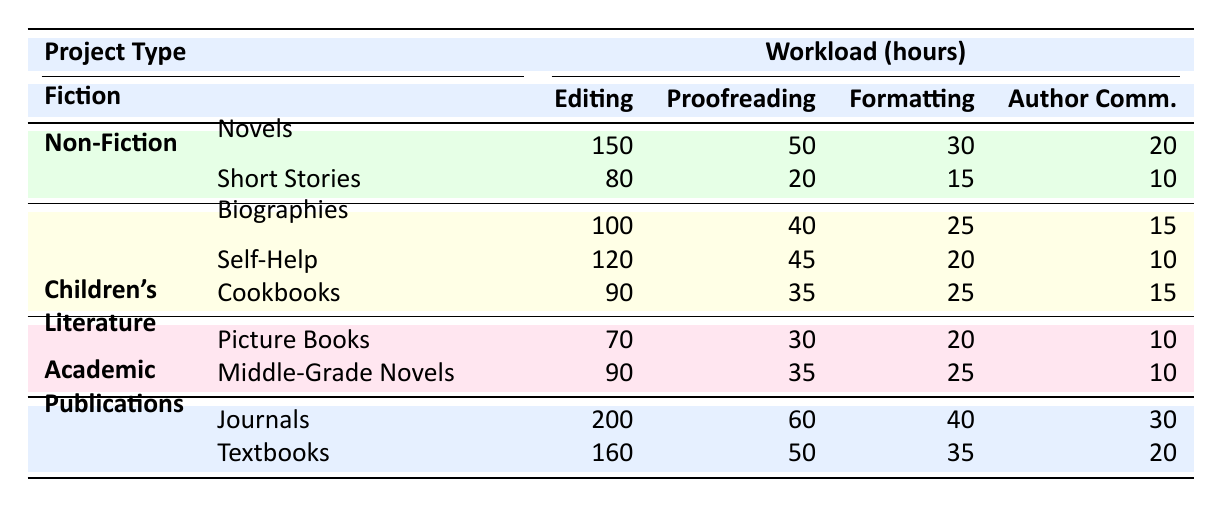What is the total editing workload for Fiction? The total editing workload for Fiction includes the editing hours for Novels (150) and Short Stories (80). Therefore, the total is calculated as 150 + 80 = 230 hours.
Answer: 230 Which project type has the highest proofreading workload? Looking at the proofreading workloads, Fiction (70), Non-Fiction (120), Children's Literature (65), and Academic Publications (110). The highest proofreading workload is for Academic Publications (60), specifically from Journals (60).
Answer: Academic Publications What is the average formatting workload for Non-Fiction? For Non-Fiction, the formatting workloads are Cookbooks (25), Biographies (25), and Self-Help (20). The total is 25 + 25 + 20 = 70. There are 3 projects, so the average is 70 / 3 = 23.33 hours.
Answer: 23.33 Is the Author Communications workload for Picture Books greater than that for Short Stories? The Author Communications workload for Picture Books is 10, while for Short Stories it is 10. Since both values are equal, the statement is false.
Answer: No What is the difference in total workload hours between Academic Publications and Children's Literature? The total workload for Academic Publications is determined by adding up workloads from Journals (60 + 200 + 40 + 30 = 330) and Textbooks (50 + 160 + 35 + 20 = 265), giving 330 total hours for Academic Publications. For Children’s Literature, Picture Books (30 + 70 + 20 + 10 = 130) and Middle-Grade Novels (35 + 90 + 25 + 10 = 160). Thus, total workload for Children’s Literature is 130 + 160 = 290 hours. The difference between Academic Publications (330) and Children’s Literature (290) is thus 330 - 290 = 40 hours.
Answer: 40 Which project in Non-Fiction requires the most editing hours? Within the Non-Fiction category, the editing hours for Biographies and Self-Help are 100 and 120 respectively, while Cookbooks has 90. The project with the most editing hours is therefore Self-Help at 120.
Answer: Self-Help 